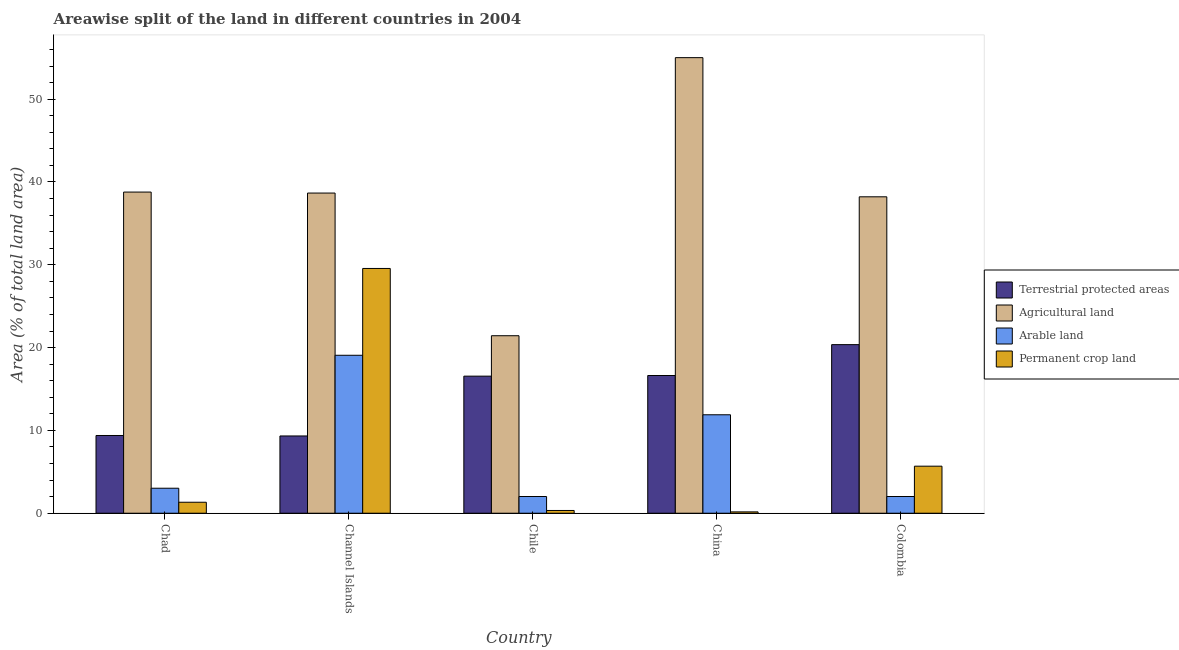How many groups of bars are there?
Your answer should be compact. 5. Are the number of bars on each tick of the X-axis equal?
Give a very brief answer. Yes. How many bars are there on the 5th tick from the left?
Your answer should be very brief. 4. How many bars are there on the 3rd tick from the right?
Make the answer very short. 4. What is the label of the 1st group of bars from the left?
Ensure brevity in your answer.  Chad. In how many cases, is the number of bars for a given country not equal to the number of legend labels?
Make the answer very short. 0. What is the percentage of area under agricultural land in China?
Offer a terse response. 55.01. Across all countries, what is the maximum percentage of area under agricultural land?
Give a very brief answer. 55.01. Across all countries, what is the minimum percentage of area under agricultural land?
Give a very brief answer. 21.43. In which country was the percentage of area under arable land maximum?
Provide a short and direct response. Channel Islands. In which country was the percentage of area under arable land minimum?
Provide a succinct answer. Colombia. What is the total percentage of area under arable land in the graph?
Offer a terse response. 38.01. What is the difference between the percentage of area under permanent crop land in Chad and that in Chile?
Provide a short and direct response. 0.99. What is the difference between the percentage of area under permanent crop land in Chile and the percentage of area under arable land in Colombia?
Provide a short and direct response. -1.69. What is the average percentage of land under terrestrial protection per country?
Keep it short and to the point. 14.45. What is the difference between the percentage of area under agricultural land and percentage of area under arable land in Chad?
Your response must be concise. 35.76. What is the ratio of the percentage of area under permanent crop land in Chad to that in Channel Islands?
Provide a succinct answer. 0.04. Is the difference between the percentage of area under agricultural land in Chad and China greater than the difference between the percentage of area under permanent crop land in Chad and China?
Your answer should be compact. No. What is the difference between the highest and the second highest percentage of land under terrestrial protection?
Provide a short and direct response. 3.73. What is the difference between the highest and the lowest percentage of land under terrestrial protection?
Your answer should be compact. 11.03. In how many countries, is the percentage of area under permanent crop land greater than the average percentage of area under permanent crop land taken over all countries?
Make the answer very short. 1. Is the sum of the percentage of area under permanent crop land in Chad and Channel Islands greater than the maximum percentage of area under arable land across all countries?
Give a very brief answer. Yes. Is it the case that in every country, the sum of the percentage of land under terrestrial protection and percentage of area under agricultural land is greater than the sum of percentage of area under arable land and percentage of area under permanent crop land?
Make the answer very short. Yes. What does the 2nd bar from the left in Channel Islands represents?
Your answer should be compact. Agricultural land. What does the 2nd bar from the right in China represents?
Keep it short and to the point. Arable land. How many bars are there?
Make the answer very short. 20. Are all the bars in the graph horizontal?
Your response must be concise. No. Are the values on the major ticks of Y-axis written in scientific E-notation?
Ensure brevity in your answer.  No. Does the graph contain grids?
Provide a short and direct response. No. What is the title of the graph?
Provide a succinct answer. Areawise split of the land in different countries in 2004. What is the label or title of the X-axis?
Your response must be concise. Country. What is the label or title of the Y-axis?
Give a very brief answer. Area (% of total land area). What is the Area (% of total land area) of Terrestrial protected areas in Chad?
Make the answer very short. 9.39. What is the Area (% of total land area) in Agricultural land in Chad?
Make the answer very short. 38.78. What is the Area (% of total land area) of Arable land in Chad?
Provide a short and direct response. 3.02. What is the Area (% of total land area) in Permanent crop land in Chad?
Your answer should be compact. 1.32. What is the Area (% of total land area) in Terrestrial protected areas in Channel Islands?
Your answer should be compact. 9.33. What is the Area (% of total land area) of Agricultural land in Channel Islands?
Give a very brief answer. 38.66. What is the Area (% of total land area) in Arable land in Channel Islands?
Keep it short and to the point. 19.07. What is the Area (% of total land area) of Permanent crop land in Channel Islands?
Give a very brief answer. 29.55. What is the Area (% of total land area) of Terrestrial protected areas in Chile?
Provide a succinct answer. 16.55. What is the Area (% of total land area) of Agricultural land in Chile?
Offer a terse response. 21.43. What is the Area (% of total land area) of Arable land in Chile?
Make the answer very short. 2.02. What is the Area (% of total land area) in Permanent crop land in Chile?
Make the answer very short. 0.33. What is the Area (% of total land area) of Terrestrial protected areas in China?
Your response must be concise. 16.63. What is the Area (% of total land area) in Agricultural land in China?
Your answer should be very brief. 55.01. What is the Area (% of total land area) of Arable land in China?
Your response must be concise. 11.89. What is the Area (% of total land area) of Permanent crop land in China?
Ensure brevity in your answer.  0.16. What is the Area (% of total land area) of Terrestrial protected areas in Colombia?
Make the answer very short. 20.36. What is the Area (% of total land area) in Agricultural land in Colombia?
Provide a short and direct response. 38.21. What is the Area (% of total land area) in Arable land in Colombia?
Keep it short and to the point. 2.02. What is the Area (% of total land area) in Permanent crop land in Colombia?
Your response must be concise. 5.68. Across all countries, what is the maximum Area (% of total land area) of Terrestrial protected areas?
Ensure brevity in your answer.  20.36. Across all countries, what is the maximum Area (% of total land area) in Agricultural land?
Ensure brevity in your answer.  55.01. Across all countries, what is the maximum Area (% of total land area) in Arable land?
Make the answer very short. 19.07. Across all countries, what is the maximum Area (% of total land area) in Permanent crop land?
Make the answer very short. 29.55. Across all countries, what is the minimum Area (% of total land area) of Terrestrial protected areas?
Ensure brevity in your answer.  9.33. Across all countries, what is the minimum Area (% of total land area) in Agricultural land?
Your response must be concise. 21.43. Across all countries, what is the minimum Area (% of total land area) in Arable land?
Provide a succinct answer. 2.02. Across all countries, what is the minimum Area (% of total land area) in Permanent crop land?
Provide a succinct answer. 0.16. What is the total Area (% of total land area) in Terrestrial protected areas in the graph?
Offer a very short reply. 72.25. What is the total Area (% of total land area) of Agricultural land in the graph?
Offer a very short reply. 192.09. What is the total Area (% of total land area) of Arable land in the graph?
Provide a succinct answer. 38.01. What is the total Area (% of total land area) in Permanent crop land in the graph?
Your answer should be compact. 37.05. What is the difference between the Area (% of total land area) of Terrestrial protected areas in Chad and that in Channel Islands?
Provide a short and direct response. 0.06. What is the difference between the Area (% of total land area) of Agricultural land in Chad and that in Channel Islands?
Keep it short and to the point. 0.12. What is the difference between the Area (% of total land area) in Arable land in Chad and that in Channel Islands?
Keep it short and to the point. -16.05. What is the difference between the Area (% of total land area) of Permanent crop land in Chad and that in Channel Islands?
Offer a very short reply. -28.23. What is the difference between the Area (% of total land area) of Terrestrial protected areas in Chad and that in Chile?
Make the answer very short. -7.17. What is the difference between the Area (% of total land area) in Agricultural land in Chad and that in Chile?
Keep it short and to the point. 17.35. What is the difference between the Area (% of total land area) of Terrestrial protected areas in Chad and that in China?
Provide a short and direct response. -7.24. What is the difference between the Area (% of total land area) of Agricultural land in Chad and that in China?
Keep it short and to the point. -16.23. What is the difference between the Area (% of total land area) in Arable land in Chad and that in China?
Ensure brevity in your answer.  -8.87. What is the difference between the Area (% of total land area) in Permanent crop land in Chad and that in China?
Your answer should be compact. 1.16. What is the difference between the Area (% of total land area) of Terrestrial protected areas in Chad and that in Colombia?
Offer a terse response. -10.97. What is the difference between the Area (% of total land area) of Agricultural land in Chad and that in Colombia?
Make the answer very short. 0.57. What is the difference between the Area (% of total land area) in Permanent crop land in Chad and that in Colombia?
Offer a terse response. -4.35. What is the difference between the Area (% of total land area) in Terrestrial protected areas in Channel Islands and that in Chile?
Your response must be concise. -7.22. What is the difference between the Area (% of total land area) in Agricultural land in Channel Islands and that in Chile?
Offer a terse response. 17.23. What is the difference between the Area (% of total land area) in Arable land in Channel Islands and that in Chile?
Make the answer very short. 17.05. What is the difference between the Area (% of total land area) in Permanent crop land in Channel Islands and that in Chile?
Make the answer very short. 29.22. What is the difference between the Area (% of total land area) in Terrestrial protected areas in Channel Islands and that in China?
Provide a succinct answer. -7.3. What is the difference between the Area (% of total land area) in Agricultural land in Channel Islands and that in China?
Your response must be concise. -16.35. What is the difference between the Area (% of total land area) of Arable land in Channel Islands and that in China?
Your answer should be compact. 7.18. What is the difference between the Area (% of total land area) in Permanent crop land in Channel Islands and that in China?
Your response must be concise. 29.39. What is the difference between the Area (% of total land area) in Terrestrial protected areas in Channel Islands and that in Colombia?
Your response must be concise. -11.03. What is the difference between the Area (% of total land area) of Agricultural land in Channel Islands and that in Colombia?
Ensure brevity in your answer.  0.45. What is the difference between the Area (% of total land area) of Arable land in Channel Islands and that in Colombia?
Keep it short and to the point. 17.05. What is the difference between the Area (% of total land area) in Permanent crop land in Channel Islands and that in Colombia?
Your response must be concise. 23.87. What is the difference between the Area (% of total land area) of Terrestrial protected areas in Chile and that in China?
Your answer should be very brief. -0.08. What is the difference between the Area (% of total land area) in Agricultural land in Chile and that in China?
Your answer should be very brief. -33.58. What is the difference between the Area (% of total land area) in Arable land in Chile and that in China?
Provide a short and direct response. -9.87. What is the difference between the Area (% of total land area) of Permanent crop land in Chile and that in China?
Ensure brevity in your answer.  0.17. What is the difference between the Area (% of total land area) in Terrestrial protected areas in Chile and that in Colombia?
Offer a terse response. -3.81. What is the difference between the Area (% of total land area) of Agricultural land in Chile and that in Colombia?
Offer a terse response. -16.78. What is the difference between the Area (% of total land area) of Permanent crop land in Chile and that in Colombia?
Your answer should be compact. -5.35. What is the difference between the Area (% of total land area) of Terrestrial protected areas in China and that in Colombia?
Provide a succinct answer. -3.73. What is the difference between the Area (% of total land area) of Agricultural land in China and that in Colombia?
Give a very brief answer. 16.8. What is the difference between the Area (% of total land area) in Arable land in China and that in Colombia?
Make the answer very short. 9.87. What is the difference between the Area (% of total land area) in Permanent crop land in China and that in Colombia?
Keep it short and to the point. -5.52. What is the difference between the Area (% of total land area) in Terrestrial protected areas in Chad and the Area (% of total land area) in Agricultural land in Channel Islands?
Your answer should be very brief. -29.27. What is the difference between the Area (% of total land area) in Terrestrial protected areas in Chad and the Area (% of total land area) in Arable land in Channel Islands?
Give a very brief answer. -9.69. What is the difference between the Area (% of total land area) in Terrestrial protected areas in Chad and the Area (% of total land area) in Permanent crop land in Channel Islands?
Make the answer very short. -20.17. What is the difference between the Area (% of total land area) of Agricultural land in Chad and the Area (% of total land area) of Arable land in Channel Islands?
Offer a terse response. 19.71. What is the difference between the Area (% of total land area) in Agricultural land in Chad and the Area (% of total land area) in Permanent crop land in Channel Islands?
Offer a very short reply. 9.22. What is the difference between the Area (% of total land area) in Arable land in Chad and the Area (% of total land area) in Permanent crop land in Channel Islands?
Provide a short and direct response. -26.54. What is the difference between the Area (% of total land area) in Terrestrial protected areas in Chad and the Area (% of total land area) in Agricultural land in Chile?
Your answer should be compact. -12.05. What is the difference between the Area (% of total land area) of Terrestrial protected areas in Chad and the Area (% of total land area) of Arable land in Chile?
Provide a succinct answer. 7.37. What is the difference between the Area (% of total land area) of Terrestrial protected areas in Chad and the Area (% of total land area) of Permanent crop land in Chile?
Offer a terse response. 9.05. What is the difference between the Area (% of total land area) in Agricultural land in Chad and the Area (% of total land area) in Arable land in Chile?
Give a very brief answer. 36.76. What is the difference between the Area (% of total land area) of Agricultural land in Chad and the Area (% of total land area) of Permanent crop land in Chile?
Your response must be concise. 38.45. What is the difference between the Area (% of total land area) of Arable land in Chad and the Area (% of total land area) of Permanent crop land in Chile?
Ensure brevity in your answer.  2.69. What is the difference between the Area (% of total land area) of Terrestrial protected areas in Chad and the Area (% of total land area) of Agricultural land in China?
Your answer should be compact. -45.62. What is the difference between the Area (% of total land area) in Terrestrial protected areas in Chad and the Area (% of total land area) in Arable land in China?
Make the answer very short. -2.5. What is the difference between the Area (% of total land area) in Terrestrial protected areas in Chad and the Area (% of total land area) in Permanent crop land in China?
Give a very brief answer. 9.22. What is the difference between the Area (% of total land area) in Agricultural land in Chad and the Area (% of total land area) in Arable land in China?
Offer a very short reply. 26.89. What is the difference between the Area (% of total land area) in Agricultural land in Chad and the Area (% of total land area) in Permanent crop land in China?
Provide a short and direct response. 38.62. What is the difference between the Area (% of total land area) in Arable land in Chad and the Area (% of total land area) in Permanent crop land in China?
Give a very brief answer. 2.86. What is the difference between the Area (% of total land area) in Terrestrial protected areas in Chad and the Area (% of total land area) in Agricultural land in Colombia?
Offer a terse response. -28.82. What is the difference between the Area (% of total land area) in Terrestrial protected areas in Chad and the Area (% of total land area) in Arable land in Colombia?
Make the answer very short. 7.37. What is the difference between the Area (% of total land area) of Terrestrial protected areas in Chad and the Area (% of total land area) of Permanent crop land in Colombia?
Offer a very short reply. 3.71. What is the difference between the Area (% of total land area) in Agricultural land in Chad and the Area (% of total land area) in Arable land in Colombia?
Your response must be concise. 36.76. What is the difference between the Area (% of total land area) in Agricultural land in Chad and the Area (% of total land area) in Permanent crop land in Colombia?
Provide a succinct answer. 33.1. What is the difference between the Area (% of total land area) of Arable land in Chad and the Area (% of total land area) of Permanent crop land in Colombia?
Offer a very short reply. -2.66. What is the difference between the Area (% of total land area) of Terrestrial protected areas in Channel Islands and the Area (% of total land area) of Agricultural land in Chile?
Offer a terse response. -12.1. What is the difference between the Area (% of total land area) in Terrestrial protected areas in Channel Islands and the Area (% of total land area) in Arable land in Chile?
Keep it short and to the point. 7.31. What is the difference between the Area (% of total land area) of Terrestrial protected areas in Channel Islands and the Area (% of total land area) of Permanent crop land in Chile?
Your answer should be compact. 9. What is the difference between the Area (% of total land area) of Agricultural land in Channel Islands and the Area (% of total land area) of Arable land in Chile?
Ensure brevity in your answer.  36.64. What is the difference between the Area (% of total land area) in Agricultural land in Channel Islands and the Area (% of total land area) in Permanent crop land in Chile?
Your answer should be very brief. 38.33. What is the difference between the Area (% of total land area) in Arable land in Channel Islands and the Area (% of total land area) in Permanent crop land in Chile?
Offer a very short reply. 18.74. What is the difference between the Area (% of total land area) in Terrestrial protected areas in Channel Islands and the Area (% of total land area) in Agricultural land in China?
Your response must be concise. -45.68. What is the difference between the Area (% of total land area) in Terrestrial protected areas in Channel Islands and the Area (% of total land area) in Arable land in China?
Provide a short and direct response. -2.56. What is the difference between the Area (% of total land area) of Terrestrial protected areas in Channel Islands and the Area (% of total land area) of Permanent crop land in China?
Provide a short and direct response. 9.17. What is the difference between the Area (% of total land area) in Agricultural land in Channel Islands and the Area (% of total land area) in Arable land in China?
Ensure brevity in your answer.  26.77. What is the difference between the Area (% of total land area) of Agricultural land in Channel Islands and the Area (% of total land area) of Permanent crop land in China?
Give a very brief answer. 38.5. What is the difference between the Area (% of total land area) of Arable land in Channel Islands and the Area (% of total land area) of Permanent crop land in China?
Keep it short and to the point. 18.91. What is the difference between the Area (% of total land area) of Terrestrial protected areas in Channel Islands and the Area (% of total land area) of Agricultural land in Colombia?
Your response must be concise. -28.88. What is the difference between the Area (% of total land area) of Terrestrial protected areas in Channel Islands and the Area (% of total land area) of Arable land in Colombia?
Make the answer very short. 7.31. What is the difference between the Area (% of total land area) in Terrestrial protected areas in Channel Islands and the Area (% of total land area) in Permanent crop land in Colombia?
Provide a short and direct response. 3.65. What is the difference between the Area (% of total land area) in Agricultural land in Channel Islands and the Area (% of total land area) in Arable land in Colombia?
Your answer should be compact. 36.64. What is the difference between the Area (% of total land area) in Agricultural land in Channel Islands and the Area (% of total land area) in Permanent crop land in Colombia?
Your response must be concise. 32.98. What is the difference between the Area (% of total land area) in Arable land in Channel Islands and the Area (% of total land area) in Permanent crop land in Colombia?
Your answer should be very brief. 13.39. What is the difference between the Area (% of total land area) in Terrestrial protected areas in Chile and the Area (% of total land area) in Agricultural land in China?
Offer a very short reply. -38.46. What is the difference between the Area (% of total land area) of Terrestrial protected areas in Chile and the Area (% of total land area) of Arable land in China?
Offer a terse response. 4.66. What is the difference between the Area (% of total land area) of Terrestrial protected areas in Chile and the Area (% of total land area) of Permanent crop land in China?
Give a very brief answer. 16.39. What is the difference between the Area (% of total land area) of Agricultural land in Chile and the Area (% of total land area) of Arable land in China?
Provide a short and direct response. 9.54. What is the difference between the Area (% of total land area) of Agricultural land in Chile and the Area (% of total land area) of Permanent crop land in China?
Your response must be concise. 21.27. What is the difference between the Area (% of total land area) in Arable land in Chile and the Area (% of total land area) in Permanent crop land in China?
Ensure brevity in your answer.  1.86. What is the difference between the Area (% of total land area) of Terrestrial protected areas in Chile and the Area (% of total land area) of Agricultural land in Colombia?
Ensure brevity in your answer.  -21.66. What is the difference between the Area (% of total land area) in Terrestrial protected areas in Chile and the Area (% of total land area) in Arable land in Colombia?
Provide a succinct answer. 14.53. What is the difference between the Area (% of total land area) in Terrestrial protected areas in Chile and the Area (% of total land area) in Permanent crop land in Colombia?
Make the answer very short. 10.87. What is the difference between the Area (% of total land area) in Agricultural land in Chile and the Area (% of total land area) in Arable land in Colombia?
Provide a succinct answer. 19.41. What is the difference between the Area (% of total land area) in Agricultural land in Chile and the Area (% of total land area) in Permanent crop land in Colombia?
Ensure brevity in your answer.  15.75. What is the difference between the Area (% of total land area) of Arable land in Chile and the Area (% of total land area) of Permanent crop land in Colombia?
Keep it short and to the point. -3.66. What is the difference between the Area (% of total land area) in Terrestrial protected areas in China and the Area (% of total land area) in Agricultural land in Colombia?
Provide a short and direct response. -21.58. What is the difference between the Area (% of total land area) in Terrestrial protected areas in China and the Area (% of total land area) in Arable land in Colombia?
Your answer should be compact. 14.61. What is the difference between the Area (% of total land area) of Terrestrial protected areas in China and the Area (% of total land area) of Permanent crop land in Colombia?
Keep it short and to the point. 10.95. What is the difference between the Area (% of total land area) of Agricultural land in China and the Area (% of total land area) of Arable land in Colombia?
Make the answer very short. 52.99. What is the difference between the Area (% of total land area) of Agricultural land in China and the Area (% of total land area) of Permanent crop land in Colombia?
Your answer should be compact. 49.33. What is the difference between the Area (% of total land area) in Arable land in China and the Area (% of total land area) in Permanent crop land in Colombia?
Offer a terse response. 6.21. What is the average Area (% of total land area) in Terrestrial protected areas per country?
Make the answer very short. 14.45. What is the average Area (% of total land area) of Agricultural land per country?
Ensure brevity in your answer.  38.42. What is the average Area (% of total land area) of Arable land per country?
Give a very brief answer. 7.6. What is the average Area (% of total land area) in Permanent crop land per country?
Your answer should be compact. 7.41. What is the difference between the Area (% of total land area) of Terrestrial protected areas and Area (% of total land area) of Agricultural land in Chad?
Provide a succinct answer. -29.39. What is the difference between the Area (% of total land area) in Terrestrial protected areas and Area (% of total land area) in Arable land in Chad?
Provide a short and direct response. 6.37. What is the difference between the Area (% of total land area) of Terrestrial protected areas and Area (% of total land area) of Permanent crop land in Chad?
Your answer should be very brief. 8.06. What is the difference between the Area (% of total land area) in Agricultural land and Area (% of total land area) in Arable land in Chad?
Your answer should be compact. 35.76. What is the difference between the Area (% of total land area) in Agricultural land and Area (% of total land area) in Permanent crop land in Chad?
Offer a terse response. 37.45. What is the difference between the Area (% of total land area) of Arable land and Area (% of total land area) of Permanent crop land in Chad?
Provide a short and direct response. 1.69. What is the difference between the Area (% of total land area) in Terrestrial protected areas and Area (% of total land area) in Agricultural land in Channel Islands?
Give a very brief answer. -29.33. What is the difference between the Area (% of total land area) in Terrestrial protected areas and Area (% of total land area) in Arable land in Channel Islands?
Your answer should be very brief. -9.74. What is the difference between the Area (% of total land area) in Terrestrial protected areas and Area (% of total land area) in Permanent crop land in Channel Islands?
Make the answer very short. -20.22. What is the difference between the Area (% of total land area) in Agricultural land and Area (% of total land area) in Arable land in Channel Islands?
Provide a succinct answer. 19.59. What is the difference between the Area (% of total land area) of Agricultural land and Area (% of total land area) of Permanent crop land in Channel Islands?
Your answer should be compact. 9.11. What is the difference between the Area (% of total land area) of Arable land and Area (% of total land area) of Permanent crop land in Channel Islands?
Your answer should be compact. -10.48. What is the difference between the Area (% of total land area) in Terrestrial protected areas and Area (% of total land area) in Agricultural land in Chile?
Offer a terse response. -4.88. What is the difference between the Area (% of total land area) of Terrestrial protected areas and Area (% of total land area) of Arable land in Chile?
Make the answer very short. 14.53. What is the difference between the Area (% of total land area) of Terrestrial protected areas and Area (% of total land area) of Permanent crop land in Chile?
Provide a succinct answer. 16.22. What is the difference between the Area (% of total land area) of Agricultural land and Area (% of total land area) of Arable land in Chile?
Your response must be concise. 19.41. What is the difference between the Area (% of total land area) of Agricultural land and Area (% of total land area) of Permanent crop land in Chile?
Provide a succinct answer. 21.1. What is the difference between the Area (% of total land area) in Arable land and Area (% of total land area) in Permanent crop land in Chile?
Your answer should be very brief. 1.69. What is the difference between the Area (% of total land area) in Terrestrial protected areas and Area (% of total land area) in Agricultural land in China?
Keep it short and to the point. -38.38. What is the difference between the Area (% of total land area) in Terrestrial protected areas and Area (% of total land area) in Arable land in China?
Your answer should be compact. 4.74. What is the difference between the Area (% of total land area) of Terrestrial protected areas and Area (% of total land area) of Permanent crop land in China?
Your response must be concise. 16.47. What is the difference between the Area (% of total land area) in Agricultural land and Area (% of total land area) in Arable land in China?
Your answer should be very brief. 43.12. What is the difference between the Area (% of total land area) in Agricultural land and Area (% of total land area) in Permanent crop land in China?
Provide a succinct answer. 54.85. What is the difference between the Area (% of total land area) in Arable land and Area (% of total land area) in Permanent crop land in China?
Your answer should be very brief. 11.73. What is the difference between the Area (% of total land area) of Terrestrial protected areas and Area (% of total land area) of Agricultural land in Colombia?
Give a very brief answer. -17.85. What is the difference between the Area (% of total land area) in Terrestrial protected areas and Area (% of total land area) in Arable land in Colombia?
Offer a terse response. 18.34. What is the difference between the Area (% of total land area) in Terrestrial protected areas and Area (% of total land area) in Permanent crop land in Colombia?
Provide a succinct answer. 14.68. What is the difference between the Area (% of total land area) in Agricultural land and Area (% of total land area) in Arable land in Colombia?
Ensure brevity in your answer.  36.19. What is the difference between the Area (% of total land area) of Agricultural land and Area (% of total land area) of Permanent crop land in Colombia?
Offer a very short reply. 32.53. What is the difference between the Area (% of total land area) in Arable land and Area (% of total land area) in Permanent crop land in Colombia?
Ensure brevity in your answer.  -3.66. What is the ratio of the Area (% of total land area) of Arable land in Chad to that in Channel Islands?
Your response must be concise. 0.16. What is the ratio of the Area (% of total land area) in Permanent crop land in Chad to that in Channel Islands?
Ensure brevity in your answer.  0.04. What is the ratio of the Area (% of total land area) in Terrestrial protected areas in Chad to that in Chile?
Make the answer very short. 0.57. What is the ratio of the Area (% of total land area) in Agricultural land in Chad to that in Chile?
Your answer should be compact. 1.81. What is the ratio of the Area (% of total land area) of Arable land in Chad to that in Chile?
Offer a terse response. 1.5. What is the ratio of the Area (% of total land area) of Permanent crop land in Chad to that in Chile?
Provide a succinct answer. 4. What is the ratio of the Area (% of total land area) of Terrestrial protected areas in Chad to that in China?
Make the answer very short. 0.56. What is the ratio of the Area (% of total land area) in Agricultural land in Chad to that in China?
Make the answer very short. 0.7. What is the ratio of the Area (% of total land area) in Arable land in Chad to that in China?
Provide a succinct answer. 0.25. What is the ratio of the Area (% of total land area) of Permanent crop land in Chad to that in China?
Offer a very short reply. 8.23. What is the ratio of the Area (% of total land area) in Terrestrial protected areas in Chad to that in Colombia?
Ensure brevity in your answer.  0.46. What is the ratio of the Area (% of total land area) in Arable land in Chad to that in Colombia?
Provide a short and direct response. 1.5. What is the ratio of the Area (% of total land area) of Permanent crop land in Chad to that in Colombia?
Keep it short and to the point. 0.23. What is the ratio of the Area (% of total land area) of Terrestrial protected areas in Channel Islands to that in Chile?
Give a very brief answer. 0.56. What is the ratio of the Area (% of total land area) in Agricultural land in Channel Islands to that in Chile?
Keep it short and to the point. 1.8. What is the ratio of the Area (% of total land area) in Arable land in Channel Islands to that in Chile?
Ensure brevity in your answer.  9.45. What is the ratio of the Area (% of total land area) in Permanent crop land in Channel Islands to that in Chile?
Your answer should be very brief. 89.33. What is the ratio of the Area (% of total land area) in Terrestrial protected areas in Channel Islands to that in China?
Give a very brief answer. 0.56. What is the ratio of the Area (% of total land area) of Agricultural land in Channel Islands to that in China?
Offer a very short reply. 0.7. What is the ratio of the Area (% of total land area) in Arable land in Channel Islands to that in China?
Your response must be concise. 1.6. What is the ratio of the Area (% of total land area) of Permanent crop land in Channel Islands to that in China?
Ensure brevity in your answer.  183.5. What is the ratio of the Area (% of total land area) of Terrestrial protected areas in Channel Islands to that in Colombia?
Your answer should be very brief. 0.46. What is the ratio of the Area (% of total land area) of Agricultural land in Channel Islands to that in Colombia?
Your response must be concise. 1.01. What is the ratio of the Area (% of total land area) in Arable land in Channel Islands to that in Colombia?
Offer a very short reply. 9.46. What is the ratio of the Area (% of total land area) of Permanent crop land in Channel Islands to that in Colombia?
Offer a very short reply. 5.2. What is the ratio of the Area (% of total land area) in Agricultural land in Chile to that in China?
Make the answer very short. 0.39. What is the ratio of the Area (% of total land area) of Arable land in Chile to that in China?
Give a very brief answer. 0.17. What is the ratio of the Area (% of total land area) of Permanent crop land in Chile to that in China?
Provide a short and direct response. 2.05. What is the ratio of the Area (% of total land area) in Terrestrial protected areas in Chile to that in Colombia?
Ensure brevity in your answer.  0.81. What is the ratio of the Area (% of total land area) in Agricultural land in Chile to that in Colombia?
Offer a terse response. 0.56. What is the ratio of the Area (% of total land area) in Arable land in Chile to that in Colombia?
Offer a very short reply. 1. What is the ratio of the Area (% of total land area) of Permanent crop land in Chile to that in Colombia?
Provide a short and direct response. 0.06. What is the ratio of the Area (% of total land area) of Terrestrial protected areas in China to that in Colombia?
Your answer should be compact. 0.82. What is the ratio of the Area (% of total land area) of Agricultural land in China to that in Colombia?
Provide a short and direct response. 1.44. What is the ratio of the Area (% of total land area) in Arable land in China to that in Colombia?
Provide a short and direct response. 5.89. What is the ratio of the Area (% of total land area) of Permanent crop land in China to that in Colombia?
Offer a very short reply. 0.03. What is the difference between the highest and the second highest Area (% of total land area) of Terrestrial protected areas?
Make the answer very short. 3.73. What is the difference between the highest and the second highest Area (% of total land area) in Agricultural land?
Ensure brevity in your answer.  16.23. What is the difference between the highest and the second highest Area (% of total land area) in Arable land?
Your answer should be compact. 7.18. What is the difference between the highest and the second highest Area (% of total land area) in Permanent crop land?
Make the answer very short. 23.87. What is the difference between the highest and the lowest Area (% of total land area) in Terrestrial protected areas?
Your response must be concise. 11.03. What is the difference between the highest and the lowest Area (% of total land area) in Agricultural land?
Give a very brief answer. 33.58. What is the difference between the highest and the lowest Area (% of total land area) of Arable land?
Ensure brevity in your answer.  17.05. What is the difference between the highest and the lowest Area (% of total land area) of Permanent crop land?
Offer a terse response. 29.39. 